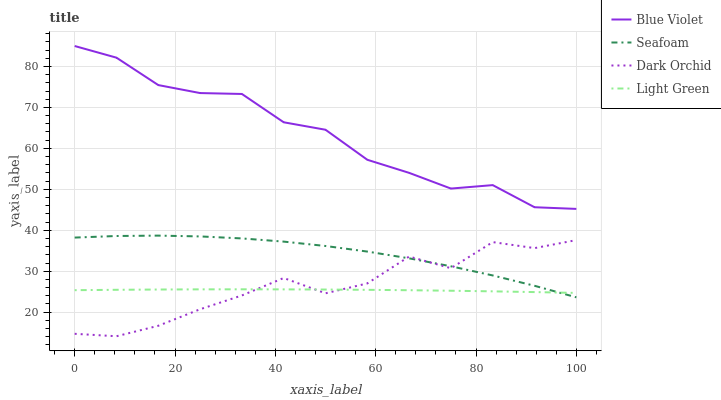Does Light Green have the minimum area under the curve?
Answer yes or no. Yes. Does Blue Violet have the maximum area under the curve?
Answer yes or no. Yes. Does Seafoam have the minimum area under the curve?
Answer yes or no. No. Does Seafoam have the maximum area under the curve?
Answer yes or no. No. Is Light Green the smoothest?
Answer yes or no. Yes. Is Dark Orchid the roughest?
Answer yes or no. Yes. Is Seafoam the smoothest?
Answer yes or no. No. Is Seafoam the roughest?
Answer yes or no. No. Does Dark Orchid have the lowest value?
Answer yes or no. Yes. Does Light Green have the lowest value?
Answer yes or no. No. Does Blue Violet have the highest value?
Answer yes or no. Yes. Does Seafoam have the highest value?
Answer yes or no. No. Is Dark Orchid less than Blue Violet?
Answer yes or no. Yes. Is Blue Violet greater than Dark Orchid?
Answer yes or no. Yes. Does Light Green intersect Seafoam?
Answer yes or no. Yes. Is Light Green less than Seafoam?
Answer yes or no. No. Is Light Green greater than Seafoam?
Answer yes or no. No. Does Dark Orchid intersect Blue Violet?
Answer yes or no. No. 